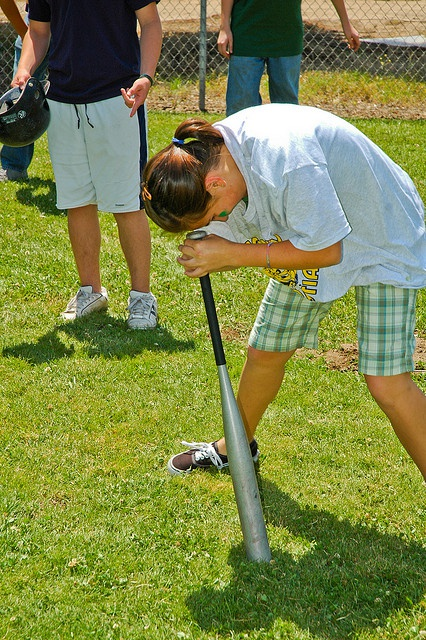Describe the objects in this image and their specific colors. I can see people in maroon, darkgray, olive, white, and lightblue tones, people in maroon, black, darkgray, brown, and olive tones, people in maroon, black, teal, brown, and olive tones, and baseball bat in maroon, darkgray, gray, and black tones in this image. 